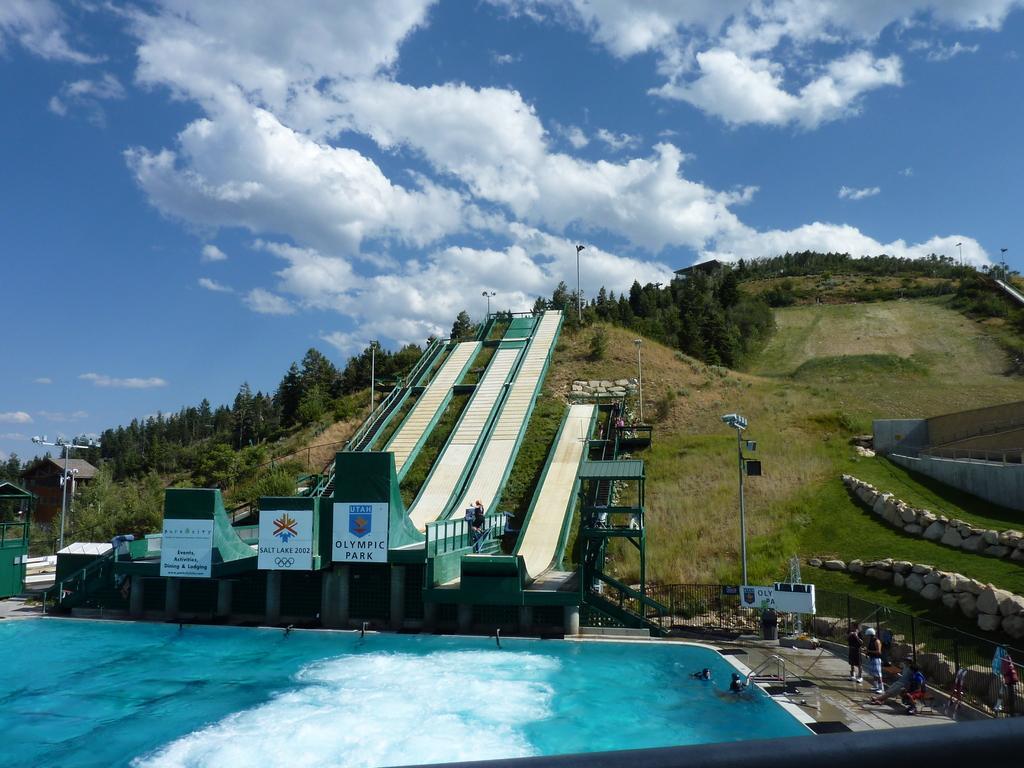In one or two sentences, can you explain what this image depicts? In this image at the bottom there is a swimming pool, and on the right side there are some persons who are standing and there is a wall and grass, pole, boards and railing. And in the background there are some trees, mountains, and slope, boards and railing. At the top of the image there is sky. 